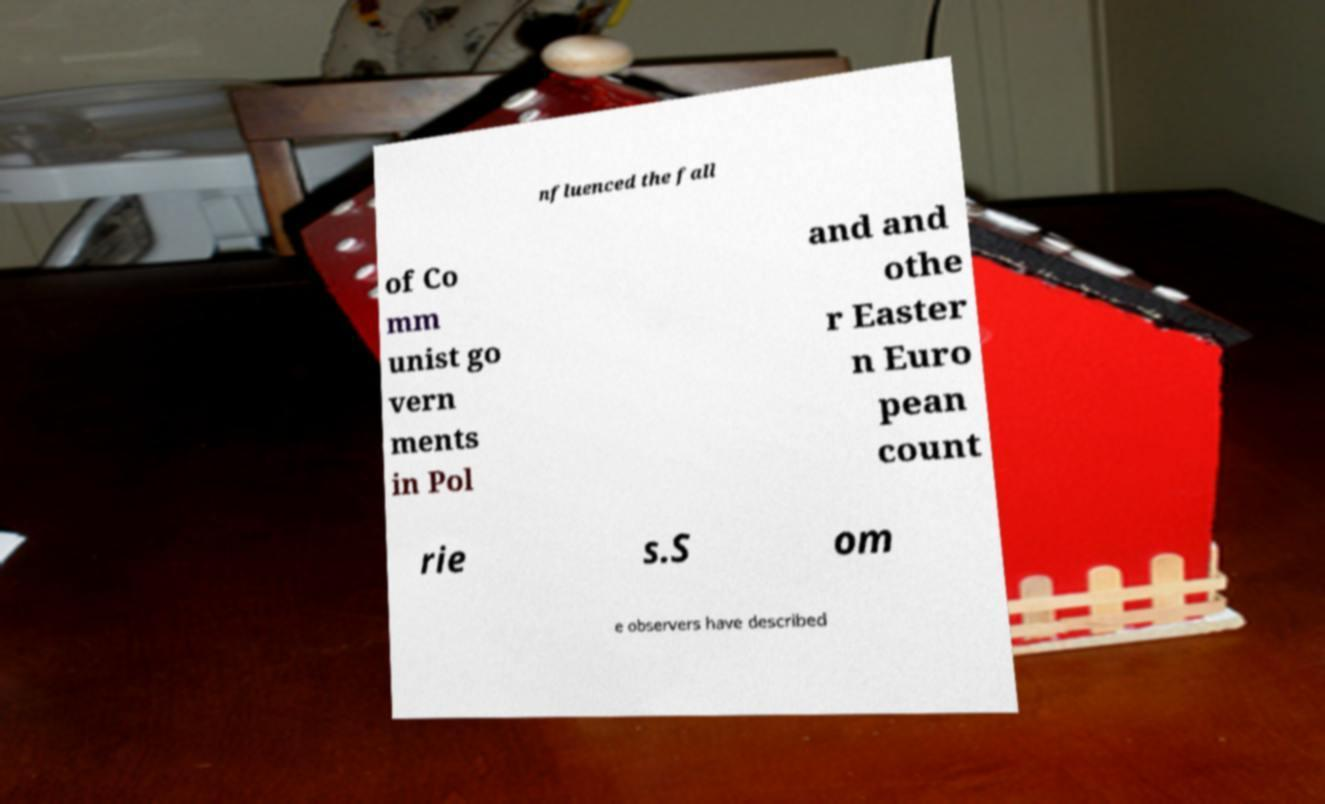Please identify and transcribe the text found in this image. nfluenced the fall of Co mm unist go vern ments in Pol and and othe r Easter n Euro pean count rie s.S om e observers have described 